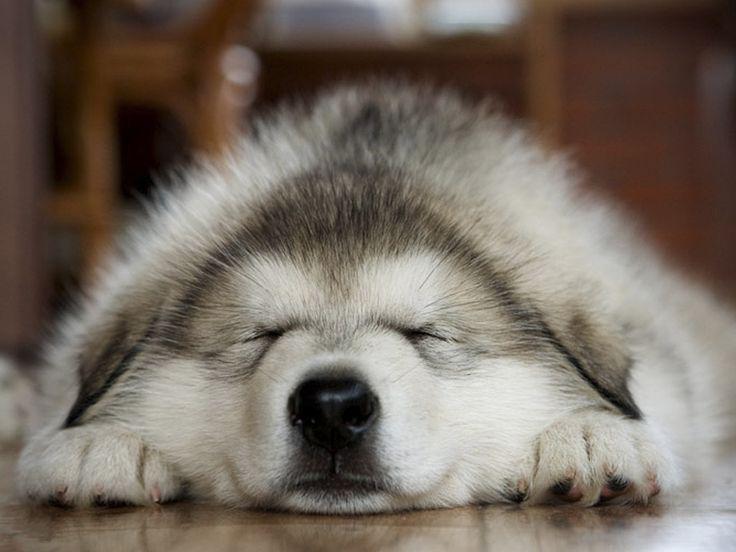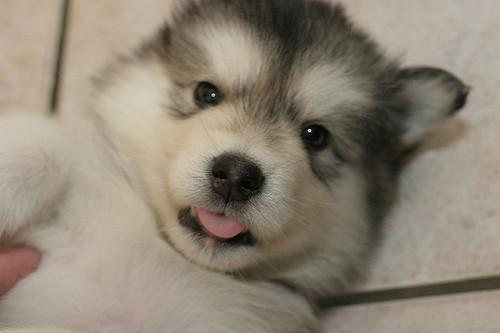The first image is the image on the left, the second image is the image on the right. For the images displayed, is the sentence "Four canines are visible." factually correct? Answer yes or no. No. The first image is the image on the left, the second image is the image on the right. For the images shown, is this caption "A dog is on its back." true? Answer yes or no. Yes. 